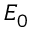Convert formula to latex. <formula><loc_0><loc_0><loc_500><loc_500>E _ { 0 }</formula> 